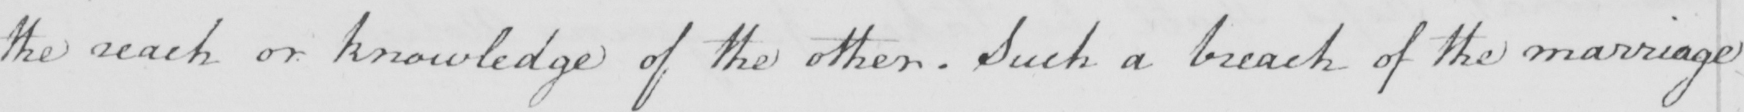What does this handwritten line say? the reach or knowledge of the other . Such a breach of the marriage 